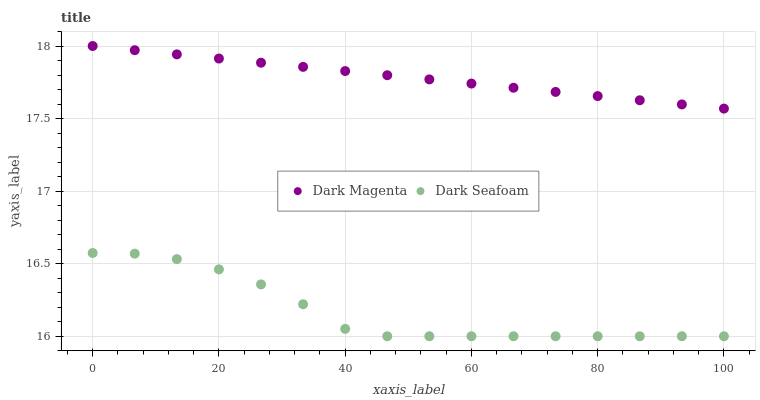Does Dark Seafoam have the minimum area under the curve?
Answer yes or no. Yes. Does Dark Magenta have the maximum area under the curve?
Answer yes or no. Yes. Does Dark Magenta have the minimum area under the curve?
Answer yes or no. No. Is Dark Magenta the smoothest?
Answer yes or no. Yes. Is Dark Seafoam the roughest?
Answer yes or no. Yes. Is Dark Magenta the roughest?
Answer yes or no. No. Does Dark Seafoam have the lowest value?
Answer yes or no. Yes. Does Dark Magenta have the lowest value?
Answer yes or no. No. Does Dark Magenta have the highest value?
Answer yes or no. Yes. Is Dark Seafoam less than Dark Magenta?
Answer yes or no. Yes. Is Dark Magenta greater than Dark Seafoam?
Answer yes or no. Yes. Does Dark Seafoam intersect Dark Magenta?
Answer yes or no. No. 